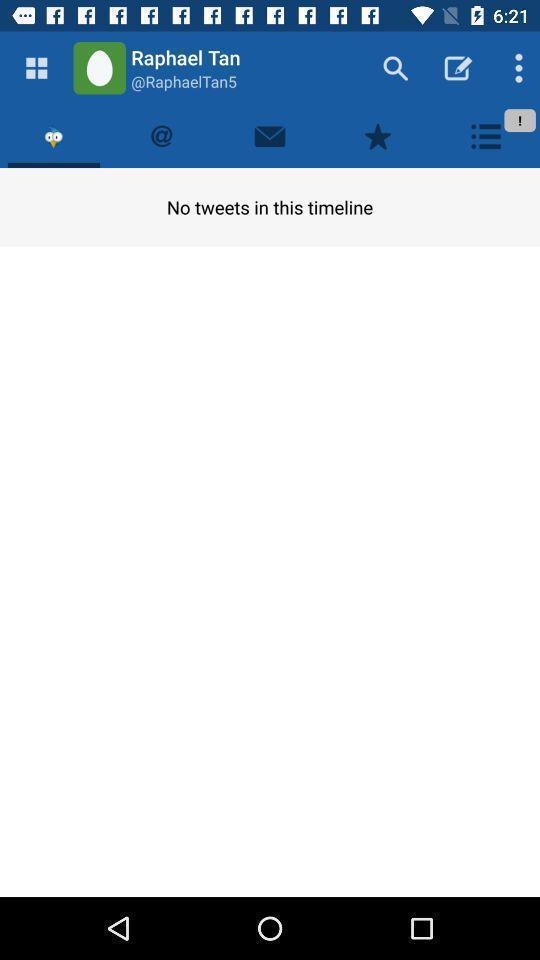Summarize the information in this screenshot. Timeline page displaying in application. 